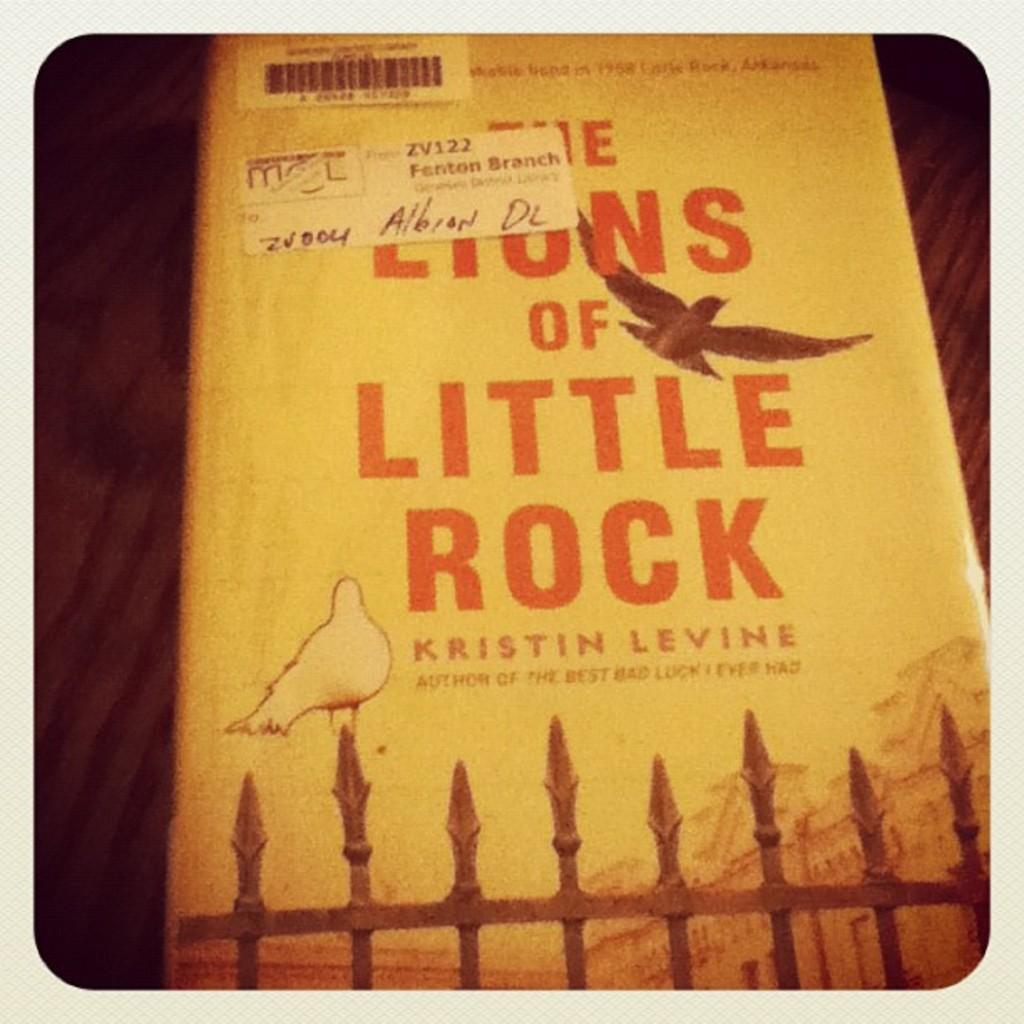<image>
Present a compact description of the photo's key features. The author of a book called The Lions of Little Rock is named Kristin Levine. 